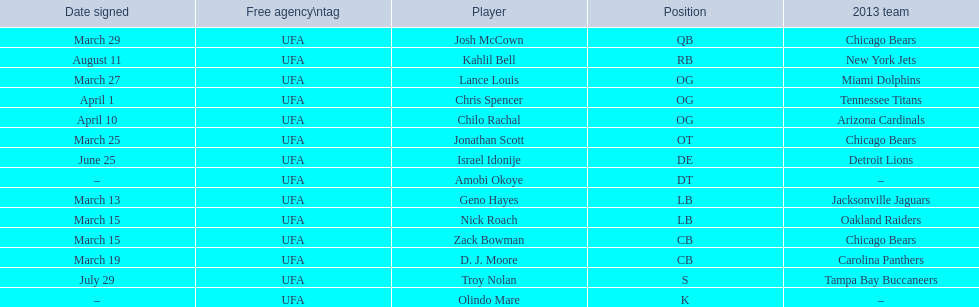What is the total of 2013 teams on the chart? 10. 